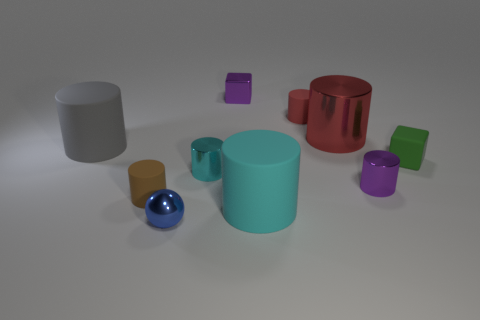Can you tell me which objects are closer to the camera? Certainly, the two objects closest to the camera are a teal-colored cylinder and a shiny blue sphere. They're placed more prominently in the foreground. 